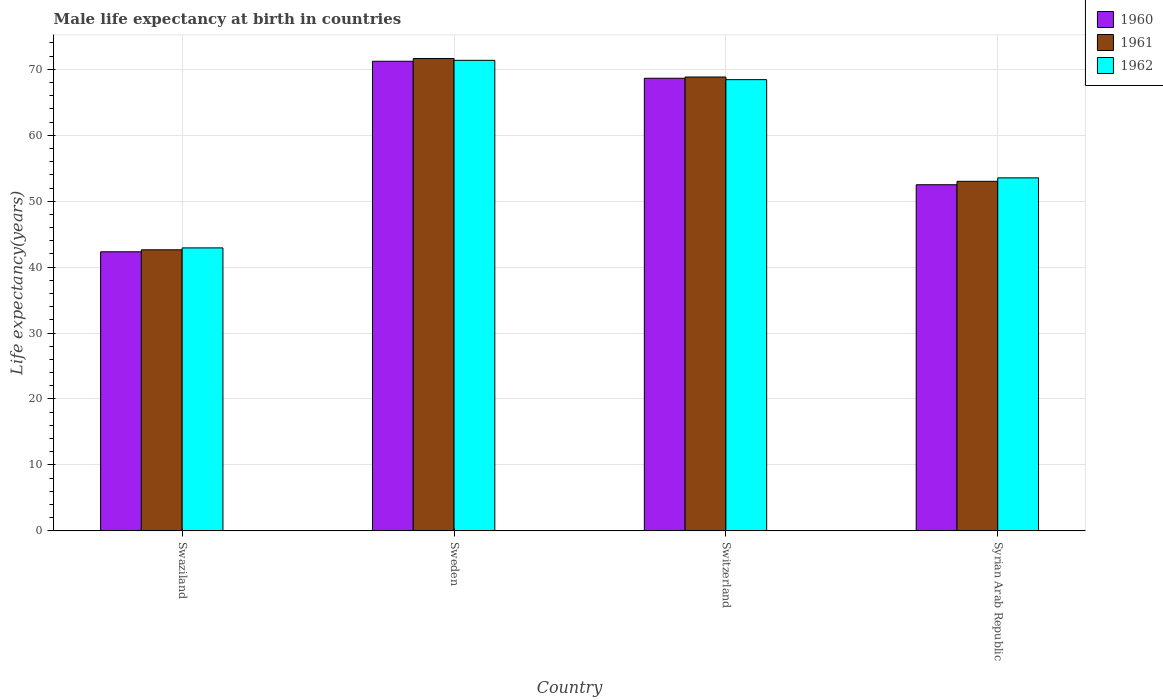How many different coloured bars are there?
Keep it short and to the point. 3. How many groups of bars are there?
Your answer should be compact. 4. How many bars are there on the 1st tick from the right?
Make the answer very short. 3. What is the label of the 4th group of bars from the left?
Your response must be concise. Syrian Arab Republic. In how many cases, is the number of bars for a given country not equal to the number of legend labels?
Provide a short and direct response. 0. What is the male life expectancy at birth in 1960 in Swaziland?
Make the answer very short. 42.33. Across all countries, what is the maximum male life expectancy at birth in 1961?
Keep it short and to the point. 71.65. Across all countries, what is the minimum male life expectancy at birth in 1961?
Keep it short and to the point. 42.63. In which country was the male life expectancy at birth in 1962 maximum?
Offer a very short reply. Sweden. In which country was the male life expectancy at birth in 1962 minimum?
Give a very brief answer. Swaziland. What is the total male life expectancy at birth in 1960 in the graph?
Keep it short and to the point. 234.7. What is the difference between the male life expectancy at birth in 1962 in Swaziland and that in Switzerland?
Provide a short and direct response. -25.52. What is the difference between the male life expectancy at birth in 1960 in Syrian Arab Republic and the male life expectancy at birth in 1962 in Swaziland?
Your answer should be compact. 9.58. What is the average male life expectancy at birth in 1962 per country?
Ensure brevity in your answer.  59.07. What is the difference between the male life expectancy at birth of/in 1961 and male life expectancy at birth of/in 1962 in Sweden?
Provide a short and direct response. 0.28. What is the ratio of the male life expectancy at birth in 1962 in Swaziland to that in Syrian Arab Republic?
Provide a short and direct response. 0.8. Is the difference between the male life expectancy at birth in 1961 in Switzerland and Syrian Arab Republic greater than the difference between the male life expectancy at birth in 1962 in Switzerland and Syrian Arab Republic?
Give a very brief answer. Yes. What is the difference between the highest and the second highest male life expectancy at birth in 1961?
Offer a terse response. 15.83. What is the difference between the highest and the lowest male life expectancy at birth in 1960?
Offer a terse response. 28.91. Is the sum of the male life expectancy at birth in 1961 in Sweden and Switzerland greater than the maximum male life expectancy at birth in 1962 across all countries?
Give a very brief answer. Yes. What does the 2nd bar from the left in Switzerland represents?
Offer a terse response. 1961. What does the 3rd bar from the right in Swaziland represents?
Your answer should be very brief. 1960. How many bars are there?
Keep it short and to the point. 12. Are all the bars in the graph horizontal?
Your answer should be very brief. No. How many countries are there in the graph?
Ensure brevity in your answer.  4. What is the difference between two consecutive major ticks on the Y-axis?
Make the answer very short. 10. Are the values on the major ticks of Y-axis written in scientific E-notation?
Offer a very short reply. No. Does the graph contain any zero values?
Give a very brief answer. No. What is the title of the graph?
Ensure brevity in your answer.  Male life expectancy at birth in countries. What is the label or title of the Y-axis?
Offer a very short reply. Life expectancy(years). What is the Life expectancy(years) of 1960 in Swaziland?
Provide a short and direct response. 42.33. What is the Life expectancy(years) in 1961 in Swaziland?
Make the answer very short. 42.63. What is the Life expectancy(years) in 1962 in Swaziland?
Offer a very short reply. 42.92. What is the Life expectancy(years) of 1960 in Sweden?
Ensure brevity in your answer.  71.23. What is the Life expectancy(years) of 1961 in Sweden?
Your answer should be very brief. 71.65. What is the Life expectancy(years) of 1962 in Sweden?
Provide a short and direct response. 71.37. What is the Life expectancy(years) of 1960 in Switzerland?
Offer a terse response. 68.65. What is the Life expectancy(years) in 1961 in Switzerland?
Offer a terse response. 68.84. What is the Life expectancy(years) of 1962 in Switzerland?
Your answer should be compact. 68.44. What is the Life expectancy(years) in 1960 in Syrian Arab Republic?
Keep it short and to the point. 52.5. What is the Life expectancy(years) of 1961 in Syrian Arab Republic?
Give a very brief answer. 53.02. What is the Life expectancy(years) in 1962 in Syrian Arab Republic?
Your answer should be very brief. 53.54. Across all countries, what is the maximum Life expectancy(years) of 1960?
Offer a terse response. 71.23. Across all countries, what is the maximum Life expectancy(years) of 1961?
Make the answer very short. 71.65. Across all countries, what is the maximum Life expectancy(years) of 1962?
Keep it short and to the point. 71.37. Across all countries, what is the minimum Life expectancy(years) of 1960?
Your answer should be very brief. 42.33. Across all countries, what is the minimum Life expectancy(years) of 1961?
Keep it short and to the point. 42.63. Across all countries, what is the minimum Life expectancy(years) in 1962?
Provide a succinct answer. 42.92. What is the total Life expectancy(years) of 1960 in the graph?
Your answer should be very brief. 234.7. What is the total Life expectancy(years) of 1961 in the graph?
Offer a very short reply. 236.13. What is the total Life expectancy(years) of 1962 in the graph?
Your response must be concise. 236.27. What is the difference between the Life expectancy(years) of 1960 in Swaziland and that in Sweden?
Provide a short and direct response. -28.91. What is the difference between the Life expectancy(years) in 1961 in Swaziland and that in Sweden?
Provide a short and direct response. -29.02. What is the difference between the Life expectancy(years) of 1962 in Swaziland and that in Sweden?
Offer a terse response. -28.45. What is the difference between the Life expectancy(years) in 1960 in Swaziland and that in Switzerland?
Offer a terse response. -26.32. What is the difference between the Life expectancy(years) of 1961 in Swaziland and that in Switzerland?
Ensure brevity in your answer.  -26.21. What is the difference between the Life expectancy(years) of 1962 in Swaziland and that in Switzerland?
Provide a succinct answer. -25.52. What is the difference between the Life expectancy(years) in 1960 in Swaziland and that in Syrian Arab Republic?
Provide a short and direct response. -10.17. What is the difference between the Life expectancy(years) of 1961 in Swaziland and that in Syrian Arab Republic?
Provide a short and direct response. -10.39. What is the difference between the Life expectancy(years) in 1962 in Swaziland and that in Syrian Arab Republic?
Keep it short and to the point. -10.62. What is the difference between the Life expectancy(years) in 1960 in Sweden and that in Switzerland?
Provide a succinct answer. 2.58. What is the difference between the Life expectancy(years) of 1961 in Sweden and that in Switzerland?
Provide a succinct answer. 2.81. What is the difference between the Life expectancy(years) in 1962 in Sweden and that in Switzerland?
Your answer should be very brief. 2.93. What is the difference between the Life expectancy(years) of 1960 in Sweden and that in Syrian Arab Republic?
Keep it short and to the point. 18.73. What is the difference between the Life expectancy(years) in 1961 in Sweden and that in Syrian Arab Republic?
Offer a terse response. 18.64. What is the difference between the Life expectancy(years) in 1962 in Sweden and that in Syrian Arab Republic?
Ensure brevity in your answer.  17.83. What is the difference between the Life expectancy(years) in 1960 in Switzerland and that in Syrian Arab Republic?
Your response must be concise. 16.15. What is the difference between the Life expectancy(years) in 1961 in Switzerland and that in Syrian Arab Republic?
Keep it short and to the point. 15.82. What is the difference between the Life expectancy(years) of 1962 in Switzerland and that in Syrian Arab Republic?
Your response must be concise. 14.9. What is the difference between the Life expectancy(years) in 1960 in Swaziland and the Life expectancy(years) in 1961 in Sweden?
Offer a very short reply. -29.32. What is the difference between the Life expectancy(years) in 1960 in Swaziland and the Life expectancy(years) in 1962 in Sweden?
Ensure brevity in your answer.  -29.05. What is the difference between the Life expectancy(years) in 1961 in Swaziland and the Life expectancy(years) in 1962 in Sweden?
Give a very brief answer. -28.74. What is the difference between the Life expectancy(years) in 1960 in Swaziland and the Life expectancy(years) in 1961 in Switzerland?
Your answer should be compact. -26.52. What is the difference between the Life expectancy(years) in 1960 in Swaziland and the Life expectancy(years) in 1962 in Switzerland?
Offer a very short reply. -26.11. What is the difference between the Life expectancy(years) of 1961 in Swaziland and the Life expectancy(years) of 1962 in Switzerland?
Keep it short and to the point. -25.81. What is the difference between the Life expectancy(years) of 1960 in Swaziland and the Life expectancy(years) of 1961 in Syrian Arab Republic?
Ensure brevity in your answer.  -10.69. What is the difference between the Life expectancy(years) in 1960 in Swaziland and the Life expectancy(years) in 1962 in Syrian Arab Republic?
Ensure brevity in your answer.  -11.21. What is the difference between the Life expectancy(years) in 1961 in Swaziland and the Life expectancy(years) in 1962 in Syrian Arab Republic?
Offer a very short reply. -10.91. What is the difference between the Life expectancy(years) of 1960 in Sweden and the Life expectancy(years) of 1961 in Switzerland?
Your response must be concise. 2.39. What is the difference between the Life expectancy(years) in 1960 in Sweden and the Life expectancy(years) in 1962 in Switzerland?
Make the answer very short. 2.79. What is the difference between the Life expectancy(years) in 1961 in Sweden and the Life expectancy(years) in 1962 in Switzerland?
Offer a terse response. 3.21. What is the difference between the Life expectancy(years) of 1960 in Sweden and the Life expectancy(years) of 1961 in Syrian Arab Republic?
Make the answer very short. 18.21. What is the difference between the Life expectancy(years) in 1960 in Sweden and the Life expectancy(years) in 1962 in Syrian Arab Republic?
Offer a very short reply. 17.69. What is the difference between the Life expectancy(years) of 1961 in Sweden and the Life expectancy(years) of 1962 in Syrian Arab Republic?
Your answer should be compact. 18.11. What is the difference between the Life expectancy(years) of 1960 in Switzerland and the Life expectancy(years) of 1961 in Syrian Arab Republic?
Provide a short and direct response. 15.63. What is the difference between the Life expectancy(years) in 1960 in Switzerland and the Life expectancy(years) in 1962 in Syrian Arab Republic?
Your response must be concise. 15.11. What is the difference between the Life expectancy(years) of 1961 in Switzerland and the Life expectancy(years) of 1962 in Syrian Arab Republic?
Make the answer very short. 15.3. What is the average Life expectancy(years) of 1960 per country?
Give a very brief answer. 58.68. What is the average Life expectancy(years) of 1961 per country?
Give a very brief answer. 59.03. What is the average Life expectancy(years) in 1962 per country?
Offer a terse response. 59.07. What is the difference between the Life expectancy(years) of 1960 and Life expectancy(years) of 1961 in Swaziland?
Your answer should be compact. -0.3. What is the difference between the Life expectancy(years) of 1960 and Life expectancy(years) of 1962 in Swaziland?
Offer a very short reply. -0.59. What is the difference between the Life expectancy(years) in 1961 and Life expectancy(years) in 1962 in Swaziland?
Your answer should be compact. -0.29. What is the difference between the Life expectancy(years) in 1960 and Life expectancy(years) in 1961 in Sweden?
Offer a very short reply. -0.42. What is the difference between the Life expectancy(years) in 1960 and Life expectancy(years) in 1962 in Sweden?
Ensure brevity in your answer.  -0.14. What is the difference between the Life expectancy(years) in 1961 and Life expectancy(years) in 1962 in Sweden?
Ensure brevity in your answer.  0.28. What is the difference between the Life expectancy(years) of 1960 and Life expectancy(years) of 1961 in Switzerland?
Provide a succinct answer. -0.19. What is the difference between the Life expectancy(years) in 1960 and Life expectancy(years) in 1962 in Switzerland?
Ensure brevity in your answer.  0.21. What is the difference between the Life expectancy(years) of 1961 and Life expectancy(years) of 1962 in Switzerland?
Keep it short and to the point. 0.4. What is the difference between the Life expectancy(years) in 1960 and Life expectancy(years) in 1961 in Syrian Arab Republic?
Provide a short and direct response. -0.52. What is the difference between the Life expectancy(years) of 1960 and Life expectancy(years) of 1962 in Syrian Arab Republic?
Keep it short and to the point. -1.04. What is the difference between the Life expectancy(years) in 1961 and Life expectancy(years) in 1962 in Syrian Arab Republic?
Your response must be concise. -0.53. What is the ratio of the Life expectancy(years) in 1960 in Swaziland to that in Sweden?
Provide a succinct answer. 0.59. What is the ratio of the Life expectancy(years) in 1961 in Swaziland to that in Sweden?
Provide a succinct answer. 0.59. What is the ratio of the Life expectancy(years) of 1962 in Swaziland to that in Sweden?
Your answer should be very brief. 0.6. What is the ratio of the Life expectancy(years) in 1960 in Swaziland to that in Switzerland?
Keep it short and to the point. 0.62. What is the ratio of the Life expectancy(years) of 1961 in Swaziland to that in Switzerland?
Provide a succinct answer. 0.62. What is the ratio of the Life expectancy(years) in 1962 in Swaziland to that in Switzerland?
Provide a succinct answer. 0.63. What is the ratio of the Life expectancy(years) of 1960 in Swaziland to that in Syrian Arab Republic?
Give a very brief answer. 0.81. What is the ratio of the Life expectancy(years) of 1961 in Swaziland to that in Syrian Arab Republic?
Ensure brevity in your answer.  0.8. What is the ratio of the Life expectancy(years) of 1962 in Swaziland to that in Syrian Arab Republic?
Provide a short and direct response. 0.8. What is the ratio of the Life expectancy(years) in 1960 in Sweden to that in Switzerland?
Keep it short and to the point. 1.04. What is the ratio of the Life expectancy(years) in 1961 in Sweden to that in Switzerland?
Give a very brief answer. 1.04. What is the ratio of the Life expectancy(years) of 1962 in Sweden to that in Switzerland?
Make the answer very short. 1.04. What is the ratio of the Life expectancy(years) of 1960 in Sweden to that in Syrian Arab Republic?
Your answer should be compact. 1.36. What is the ratio of the Life expectancy(years) in 1961 in Sweden to that in Syrian Arab Republic?
Your response must be concise. 1.35. What is the ratio of the Life expectancy(years) of 1962 in Sweden to that in Syrian Arab Republic?
Make the answer very short. 1.33. What is the ratio of the Life expectancy(years) in 1960 in Switzerland to that in Syrian Arab Republic?
Your answer should be very brief. 1.31. What is the ratio of the Life expectancy(years) in 1961 in Switzerland to that in Syrian Arab Republic?
Keep it short and to the point. 1.3. What is the ratio of the Life expectancy(years) of 1962 in Switzerland to that in Syrian Arab Republic?
Keep it short and to the point. 1.28. What is the difference between the highest and the second highest Life expectancy(years) of 1960?
Ensure brevity in your answer.  2.58. What is the difference between the highest and the second highest Life expectancy(years) in 1961?
Ensure brevity in your answer.  2.81. What is the difference between the highest and the second highest Life expectancy(years) of 1962?
Your response must be concise. 2.93. What is the difference between the highest and the lowest Life expectancy(years) in 1960?
Your response must be concise. 28.91. What is the difference between the highest and the lowest Life expectancy(years) in 1961?
Give a very brief answer. 29.02. What is the difference between the highest and the lowest Life expectancy(years) of 1962?
Provide a succinct answer. 28.45. 